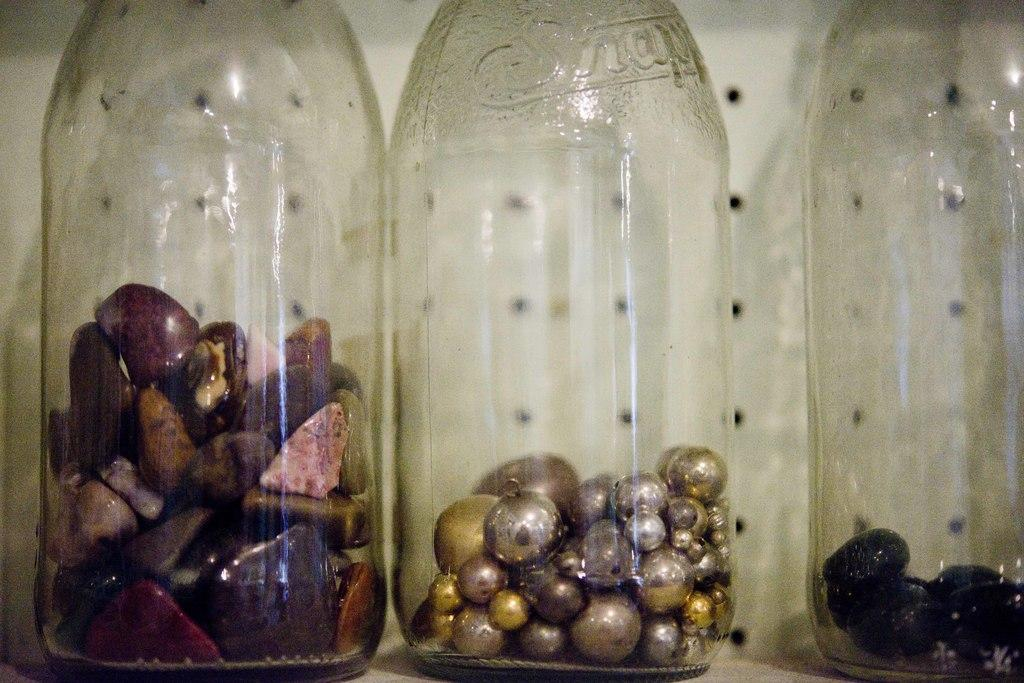Provide a one-sentence caption for the provided image. An empty Snapple bottle now contains metallic beads instead of a drink. 